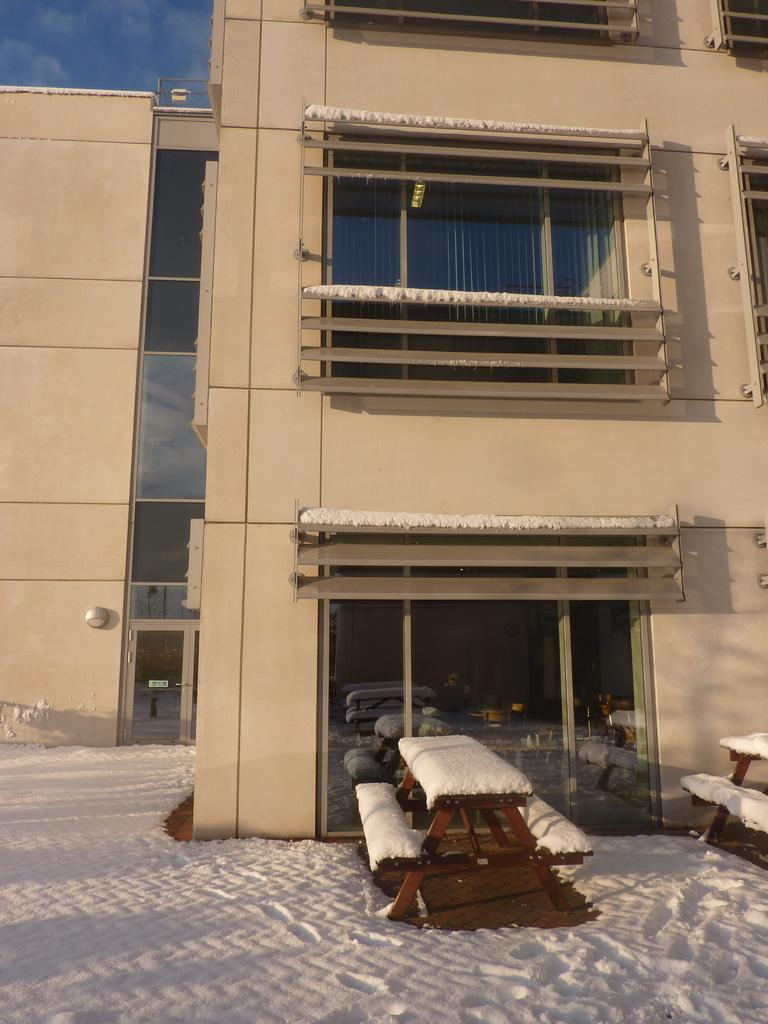What type of building is in the image? There is a building with glass windows in the image. What is the surrounding environment of the building? The building is near a snow surface. Are there any seating areas visible in the image? Yes, there are two benches on the snow surface. What can be seen at the top of the building? The sky is visible at the top of the building. What is the weather like in the image? The presence of snow and clouds suggests a cold or wintry weather. What type of car is parked on the baseball field in the image? There is no car or baseball field present in the image; it features a building near a snow surface with benches and a sky with clouds. 